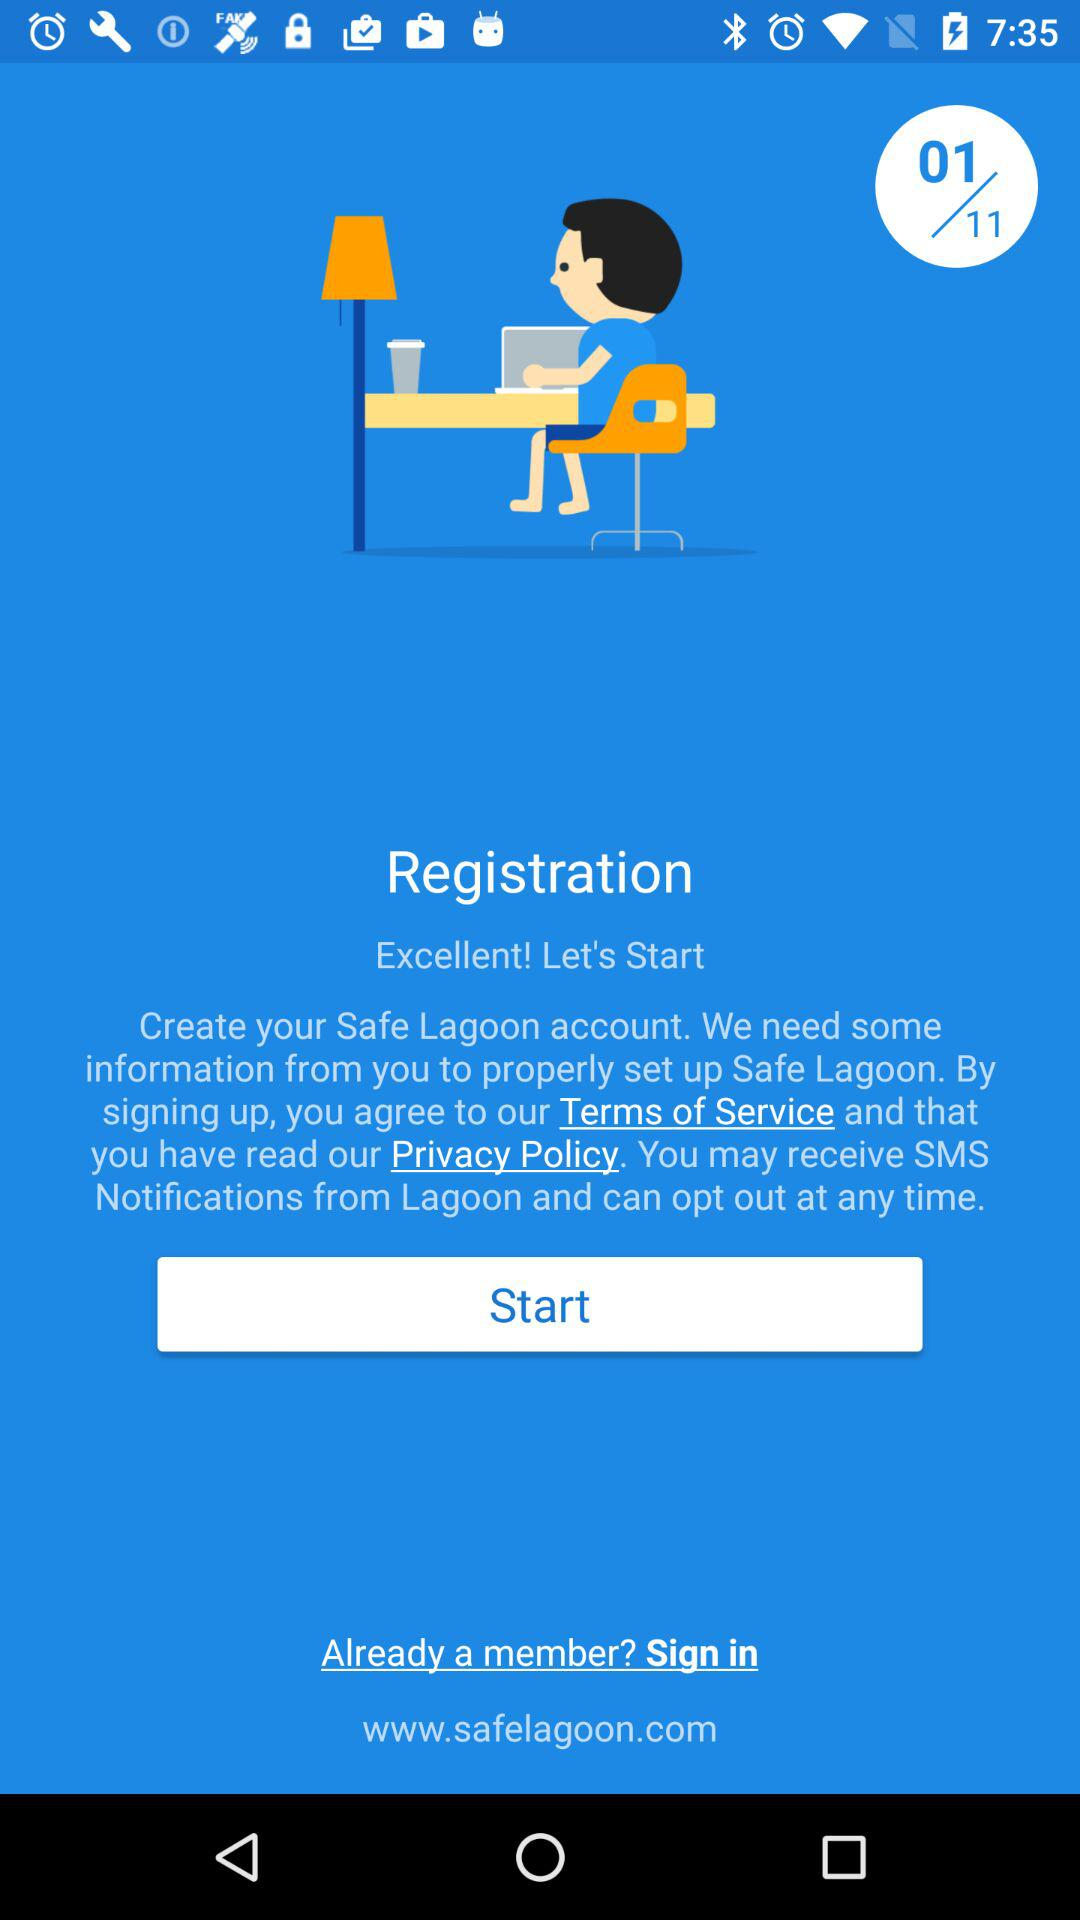Which page is open? The open page is 1. 